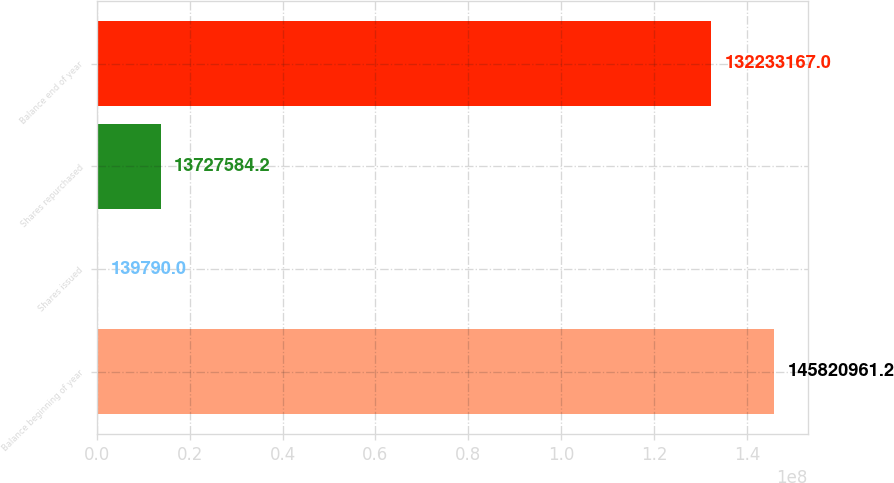Convert chart. <chart><loc_0><loc_0><loc_500><loc_500><bar_chart><fcel>Balance beginning of year<fcel>Shares issued<fcel>Shares repurchased<fcel>Balance end of year<nl><fcel>1.45821e+08<fcel>139790<fcel>1.37276e+07<fcel>1.32233e+08<nl></chart> 